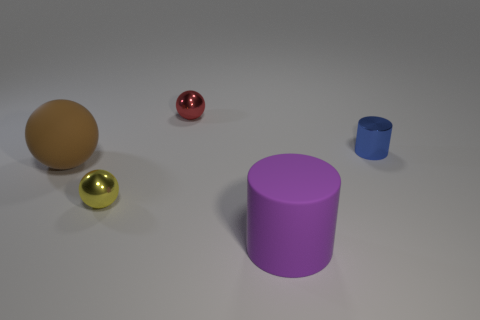How would you describe the layout of the objects on the surface? The objects are arranged on a flat surface with ample space between them. From left to right, there is a large brown sphere, a small shiny gold sphere, a larger pink cylinder, and a tiny blue cylinder, creating an interesting variety in size and color. Do the objects share any similar characteristics? Yes, all objects have a smooth texture and a matte or shiny finish, indicating they may be made of similar materials like plastic or metal. The geometric shapes – spheres and cylinders – also point to an orchestrated composition, potentially for a visual study. 